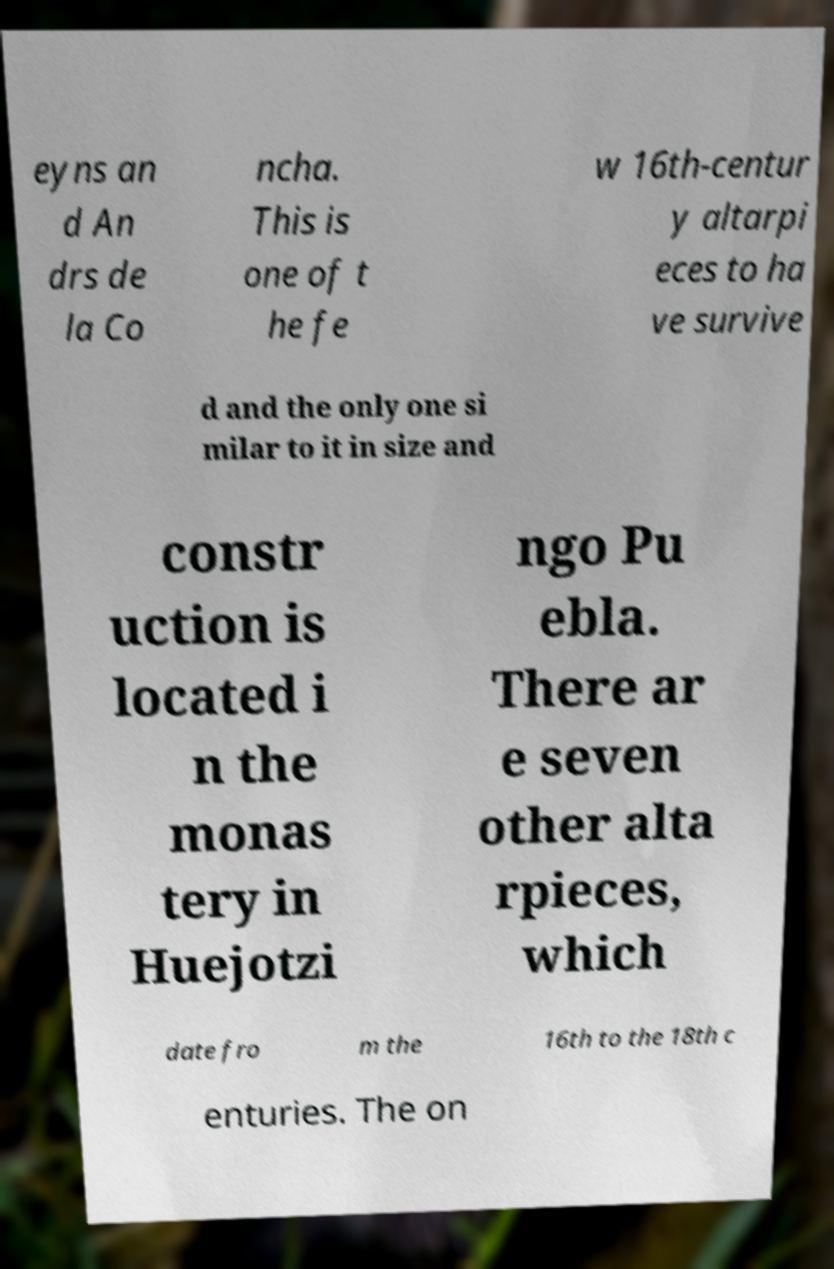Can you accurately transcribe the text from the provided image for me? eyns an d An drs de la Co ncha. This is one of t he fe w 16th-centur y altarpi eces to ha ve survive d and the only one si milar to it in size and constr uction is located i n the monas tery in Huejotzi ngo Pu ebla. There ar e seven other alta rpieces, which date fro m the 16th to the 18th c enturies. The on 